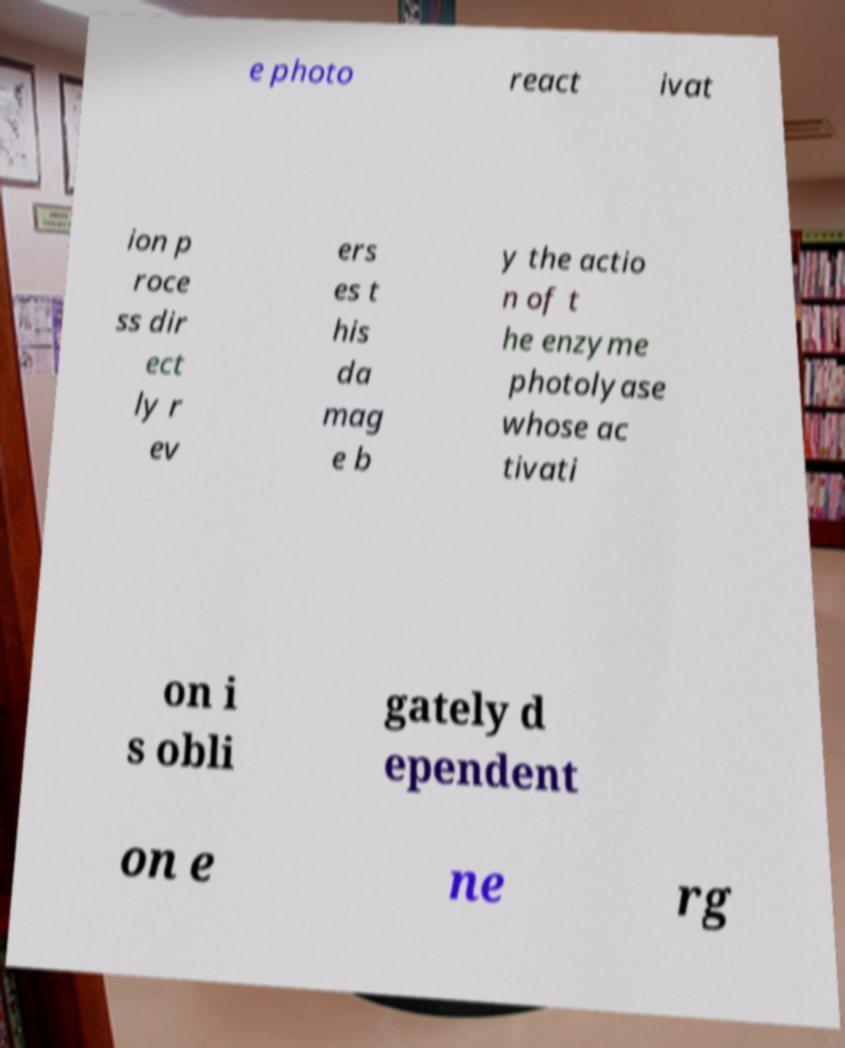Can you read and provide the text displayed in the image?This photo seems to have some interesting text. Can you extract and type it out for me? e photo react ivat ion p roce ss dir ect ly r ev ers es t his da mag e b y the actio n of t he enzyme photolyase whose ac tivati on i s obli gately d ependent on e ne rg 